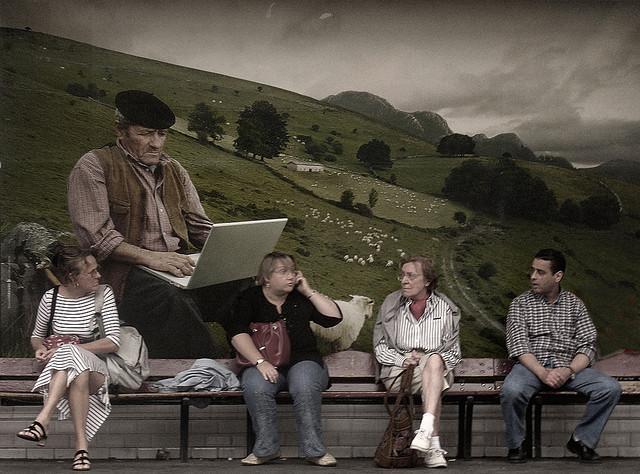What is the man in the mural using?
Choose the right answer and clarify with the format: 'Answer: answer
Rationale: rationale.'
Options: Toaster, laptop, phone, gun. Answer: laptop.
Rationale: The man has a laptop. 